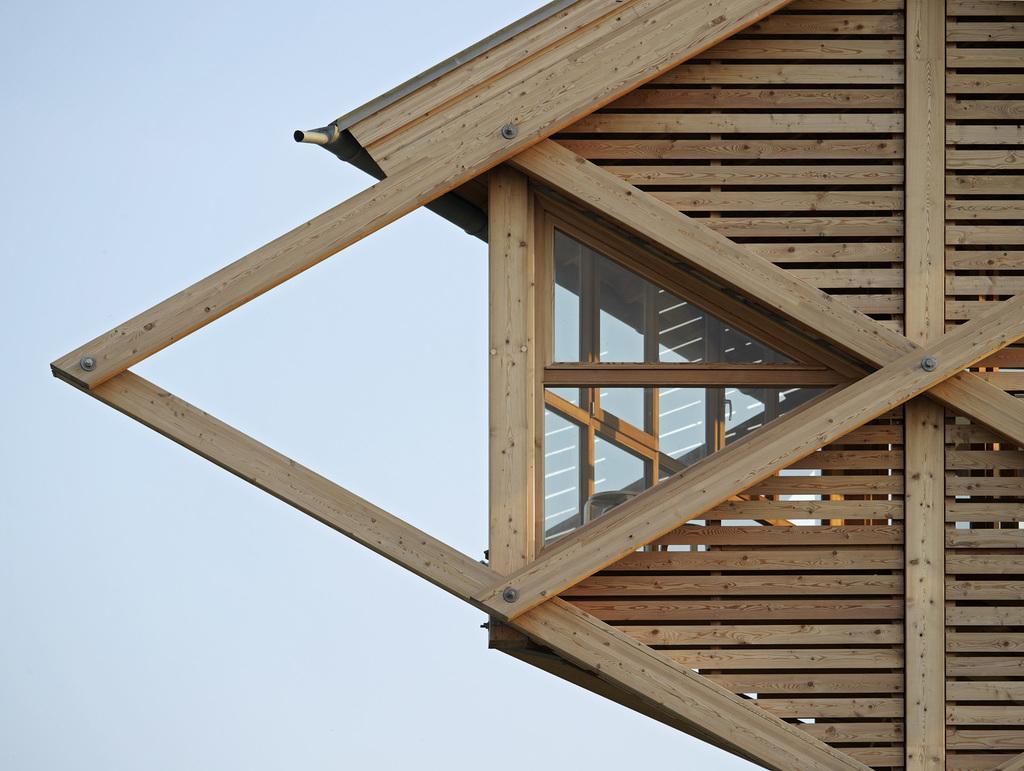In one or two sentences, can you explain what this image depicts? Here we can see half part of a house made with plywood and this is sky. 